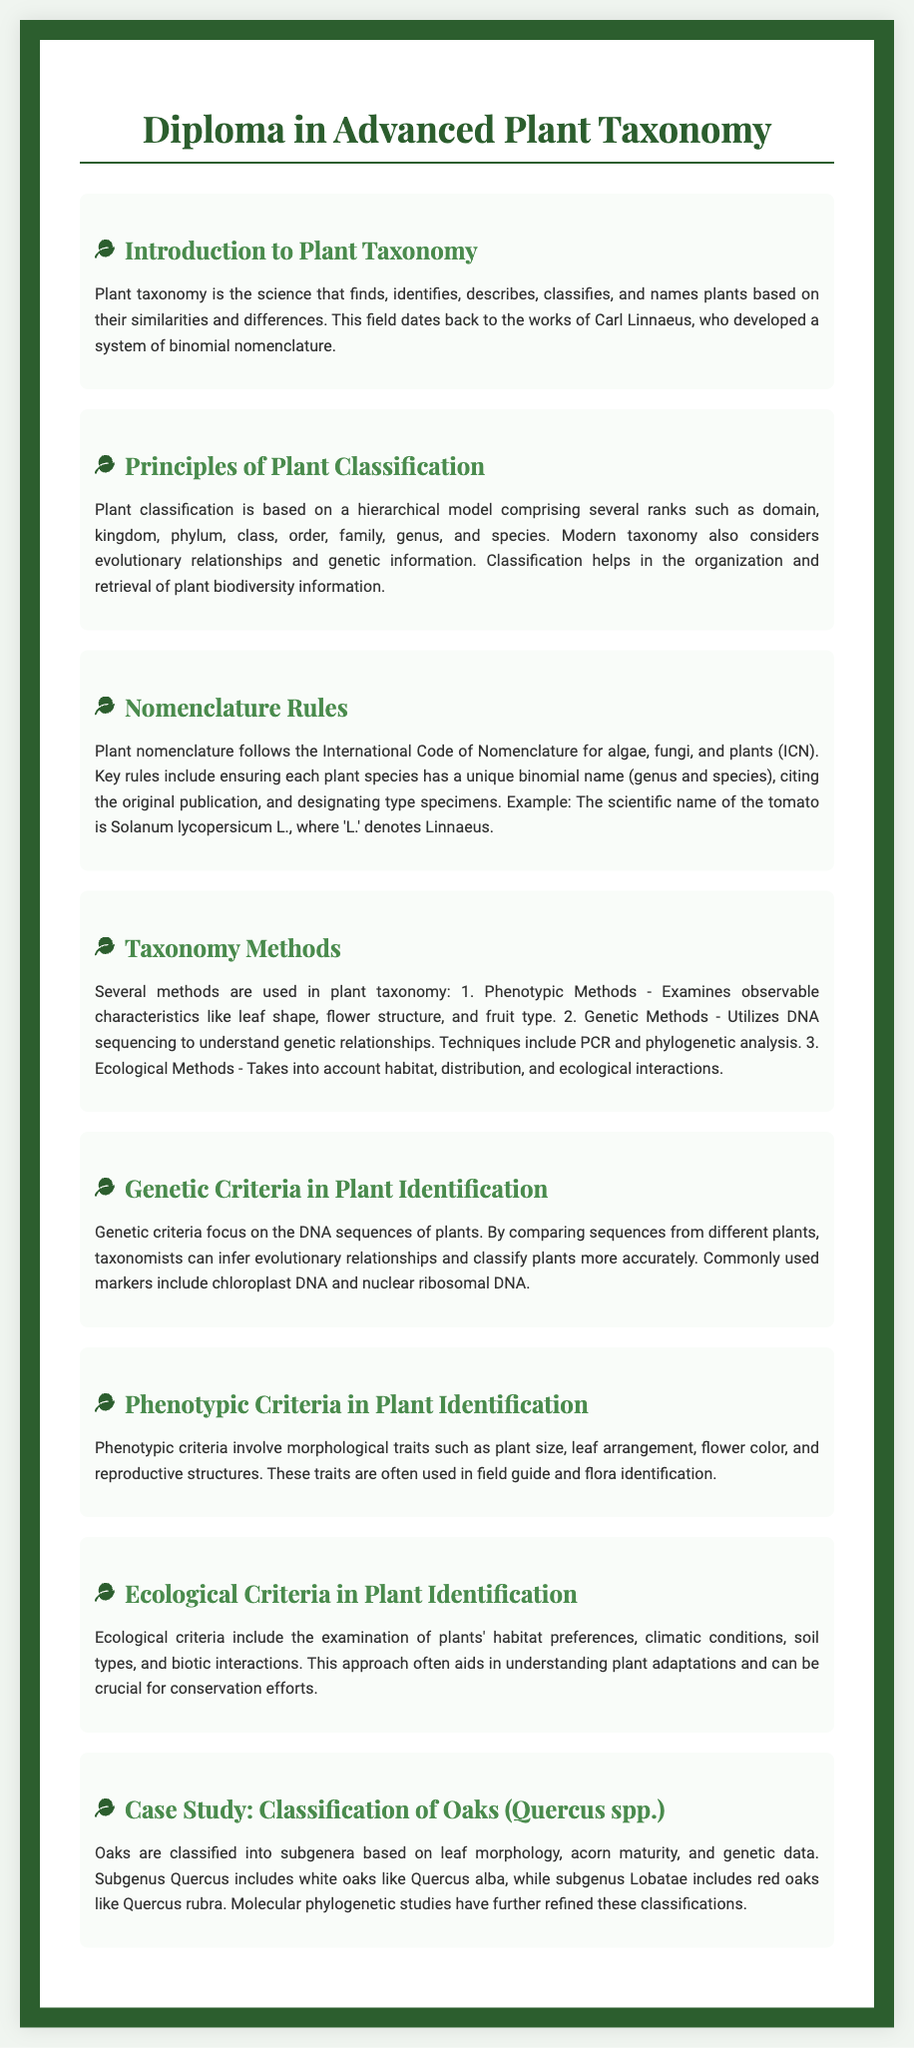What is plant taxonomy? Plant taxonomy is the science that finds, identifies, describes, classifies, and names plants based on their similarities and differences.
Answer: Science of classification What does ICN stand for? ICN stands for the International Code of Nomenclature for algae, fungi, and plants.
Answer: International Code of Nomenclature What are the ranks in plant classification? The ranks in plant classification include domain, kingdom, phylum, class, order, family, genus, and species.
Answer: Hierarchical ranks What method examines observable characteristics? The method that examines observable characteristics is called phenotypic methods.
Answer: Phenotypic methods Which subgenus includes white oaks? The subgenus that includes white oaks is Quercus.
Answer: Quercus What are commonly used genetic markers? Commonly used genetic markers include chloroplast DNA and nuclear ribosomal DNA.
Answer: Chloroplast DNA What aspect does ecological criteria focus on? Ecological criteria focus on habitat preferences, climatic conditions, soil types, and biotic interactions.
Answer: Habitat and environment Who developed the system of binomial nomenclature? The system of binomial nomenclature was developed by Carl Linnaeus.
Answer: Carl Linnaeus 